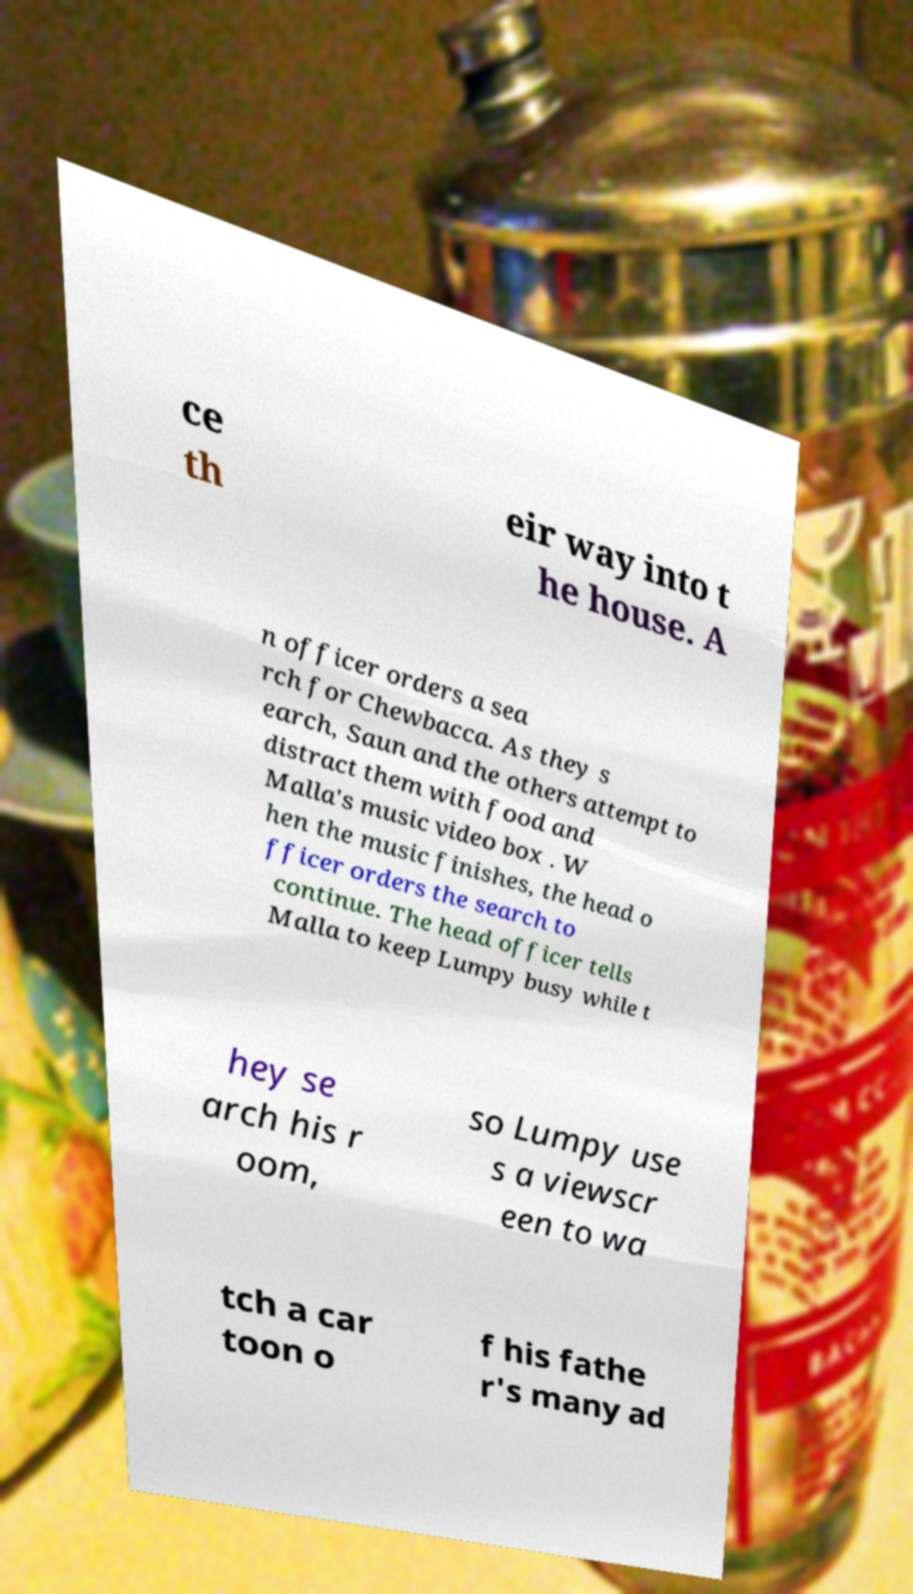Please identify and transcribe the text found in this image. ce th eir way into t he house. A n officer orders a sea rch for Chewbacca. As they s earch, Saun and the others attempt to distract them with food and Malla's music video box . W hen the music finishes, the head o fficer orders the search to continue. The head officer tells Malla to keep Lumpy busy while t hey se arch his r oom, so Lumpy use s a viewscr een to wa tch a car toon o f his fathe r's many ad 